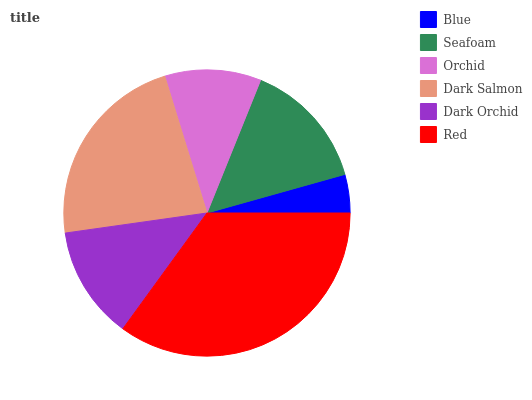Is Blue the minimum?
Answer yes or no. Yes. Is Red the maximum?
Answer yes or no. Yes. Is Seafoam the minimum?
Answer yes or no. No. Is Seafoam the maximum?
Answer yes or no. No. Is Seafoam greater than Blue?
Answer yes or no. Yes. Is Blue less than Seafoam?
Answer yes or no. Yes. Is Blue greater than Seafoam?
Answer yes or no. No. Is Seafoam less than Blue?
Answer yes or no. No. Is Seafoam the high median?
Answer yes or no. Yes. Is Dark Orchid the low median?
Answer yes or no. Yes. Is Blue the high median?
Answer yes or no. No. Is Seafoam the low median?
Answer yes or no. No. 